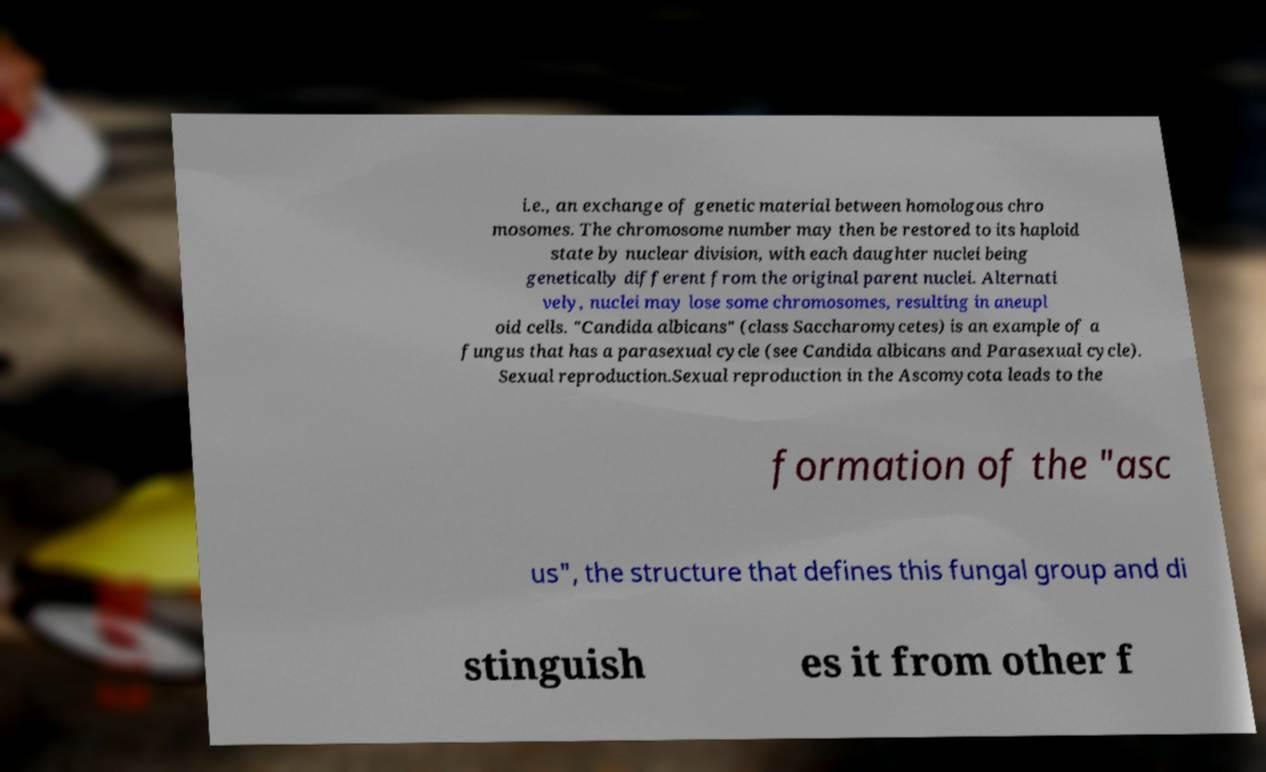Could you extract and type out the text from this image? i.e., an exchange of genetic material between homologous chro mosomes. The chromosome number may then be restored to its haploid state by nuclear division, with each daughter nuclei being genetically different from the original parent nuclei. Alternati vely, nuclei may lose some chromosomes, resulting in aneupl oid cells. "Candida albicans" (class Saccharomycetes) is an example of a fungus that has a parasexual cycle (see Candida albicans and Parasexual cycle). Sexual reproduction.Sexual reproduction in the Ascomycota leads to the formation of the "asc us", the structure that defines this fungal group and di stinguish es it from other f 